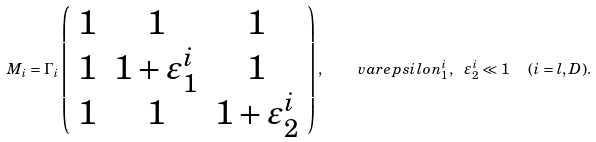<formula> <loc_0><loc_0><loc_500><loc_500>M _ { i } = \Gamma _ { i } \left ( \begin{array} { c c c } { 1 } & { 1 } & { 1 } \\ { 1 } & { { 1 + \varepsilon _ { 1 } ^ { i } } } & { 1 } \\ { 1 } & { 1 } & { { 1 + \varepsilon _ { 2 } ^ { i } } } \end{array} \right ) , \quad v a r e p s i l o n _ { 1 } ^ { i } , \ \varepsilon _ { 2 } ^ { i } \ll 1 \ \ ( i = l , D ) .</formula> 